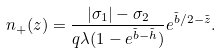<formula> <loc_0><loc_0><loc_500><loc_500>n _ { + } ( z ) = \frac { | \sigma _ { 1 } | - \sigma _ { 2 } } { q \lambda ( 1 - e ^ { \tilde { b } - \tilde { h } } ) } e ^ { \tilde { b } / 2 - \tilde { z } } .</formula> 